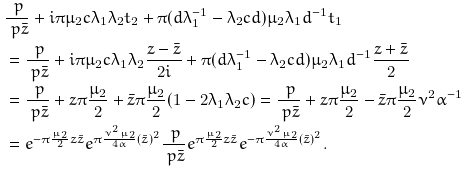<formula> <loc_0><loc_0><loc_500><loc_500>& \frac { \ p } { \ p \bar { z } } + i \pi \mu _ { 2 } c \lambda _ { 1 } \lambda _ { 2 } t _ { 2 } + \pi ( d \lambda _ { 1 } ^ { - 1 } - \lambda _ { 2 } c d ) \mu _ { 2 } \lambda _ { 1 } d ^ { - 1 } t _ { 1 } \\ & = \frac { \ p } { \ p \bar { z } } + i \pi \mu _ { 2 } c \lambda _ { 1 } \lambda _ { 2 } \frac { z - \bar { z } } { 2 i } + \pi ( d \lambda _ { 1 } ^ { - 1 } - \lambda _ { 2 } c d ) \mu _ { 2 } \lambda _ { 1 } d ^ { - 1 } \frac { z + \bar { z } } { 2 } \\ & = \frac { \ p } { \ p \bar { z } } + z \pi \frac { \mu _ { 2 } } { 2 } + \bar { z } \pi \frac { \mu _ { 2 } } 2 ( 1 - 2 \lambda _ { 1 } \lambda _ { 2 } c ) = \frac { \ p } { \ p \bar { z } } + z \pi \frac { \mu _ { 2 } } { 2 } - \bar { z } \pi \frac { \mu _ { 2 } } 2 \nu ^ { 2 } \alpha ^ { - 1 } \\ & = e ^ { - \pi \frac { \mu _ { 2 } } { 2 } z \bar { z } } e ^ { \pi \frac { \nu ^ { 2 } \mu _ { 2 } } { 4 \alpha } ( \bar { z } ) ^ { 2 } } \frac { \ p } { \ p \bar { z } } e ^ { \pi \frac { \mu _ { 2 } } { 2 } z \bar { z } } e ^ { - \pi \frac { \nu ^ { 2 } \mu _ { 2 } } { 4 \alpha } ( \bar { z } ) ^ { 2 } } .</formula> 